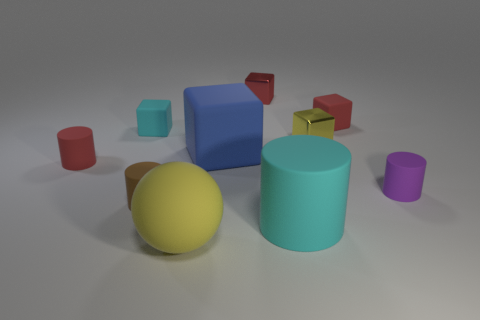Subtract all blue blocks. How many blocks are left? 4 Subtract 2 cylinders. How many cylinders are left? 2 Subtract all cyan rubber cylinders. How many cylinders are left? 3 Subtract all yellow blocks. Subtract all purple spheres. How many blocks are left? 4 Subtract all cylinders. How many objects are left? 6 Add 1 spheres. How many spheres are left? 2 Add 7 tiny purple metallic cylinders. How many tiny purple metallic cylinders exist? 7 Subtract 0 yellow cylinders. How many objects are left? 10 Subtract all tiny red cylinders. Subtract all green rubber spheres. How many objects are left? 9 